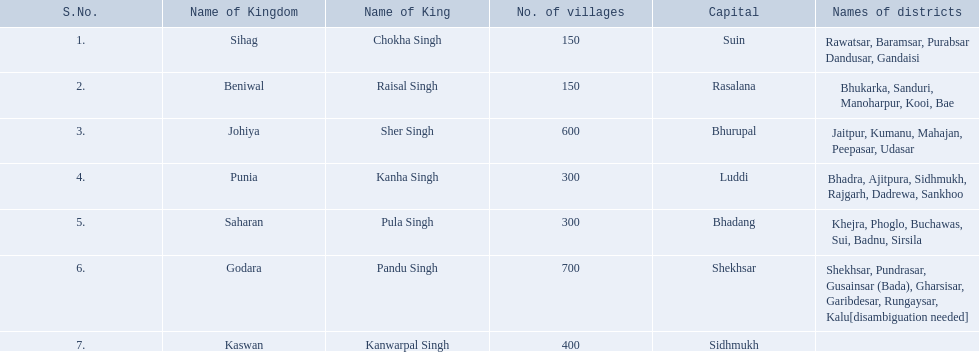Which kingdom had the lowest count of villages, considering sihag as well? Beniwal. Which kingdom had the highest count of villages? Godara. Which village had the same number of villages as godara, occupying the second position in terms of most villages? Johiya. 